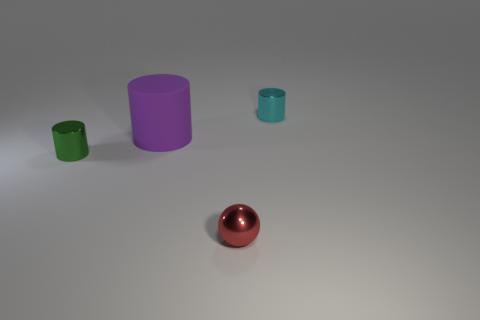Subtract all big purple matte cylinders. How many cylinders are left? 2 Subtract all green cylinders. How many cylinders are left? 2 Subtract 1 cylinders. How many cylinders are left? 2 Add 4 big purple objects. How many objects exist? 8 Subtract all balls. How many objects are left? 3 Subtract all blue spheres. How many cyan cylinders are left? 1 Subtract all large purple objects. Subtract all green cylinders. How many objects are left? 2 Add 3 large rubber cylinders. How many large rubber cylinders are left? 4 Add 2 small green shiny cylinders. How many small green shiny cylinders exist? 3 Subtract 0 blue spheres. How many objects are left? 4 